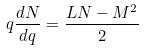Convert formula to latex. <formula><loc_0><loc_0><loc_500><loc_500>q \frac { d N } { d q } = \frac { L N - M ^ { 2 } } { 2 }</formula> 